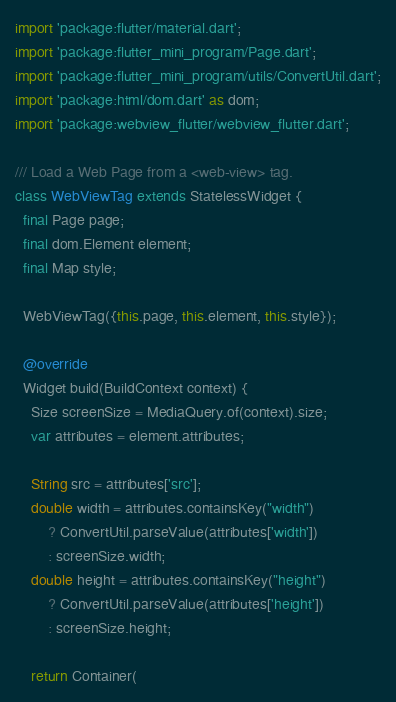Convert code to text. <code><loc_0><loc_0><loc_500><loc_500><_Dart_>import 'package:flutter/material.dart';
import 'package:flutter_mini_program/Page.dart';
import 'package:flutter_mini_program/utils/ConvertUtil.dart';
import 'package:html/dom.dart' as dom;
import 'package:webview_flutter/webview_flutter.dart';

/// Load a Web Page from a <web-view> tag.
class WebViewTag extends StatelessWidget {
  final Page page;
  final dom.Element element;
  final Map style;

  WebViewTag({this.page, this.element, this.style});

  @override
  Widget build(BuildContext context) {
    Size screenSize = MediaQuery.of(context).size;
    var attributes = element.attributes;

    String src = attributes['src'];
    double width = attributes.containsKey("width")
        ? ConvertUtil.parseValue(attributes['width'])
        : screenSize.width;
    double height = attributes.containsKey("height")
        ? ConvertUtil.parseValue(attributes['height'])
        : screenSize.height;

    return Container(</code> 